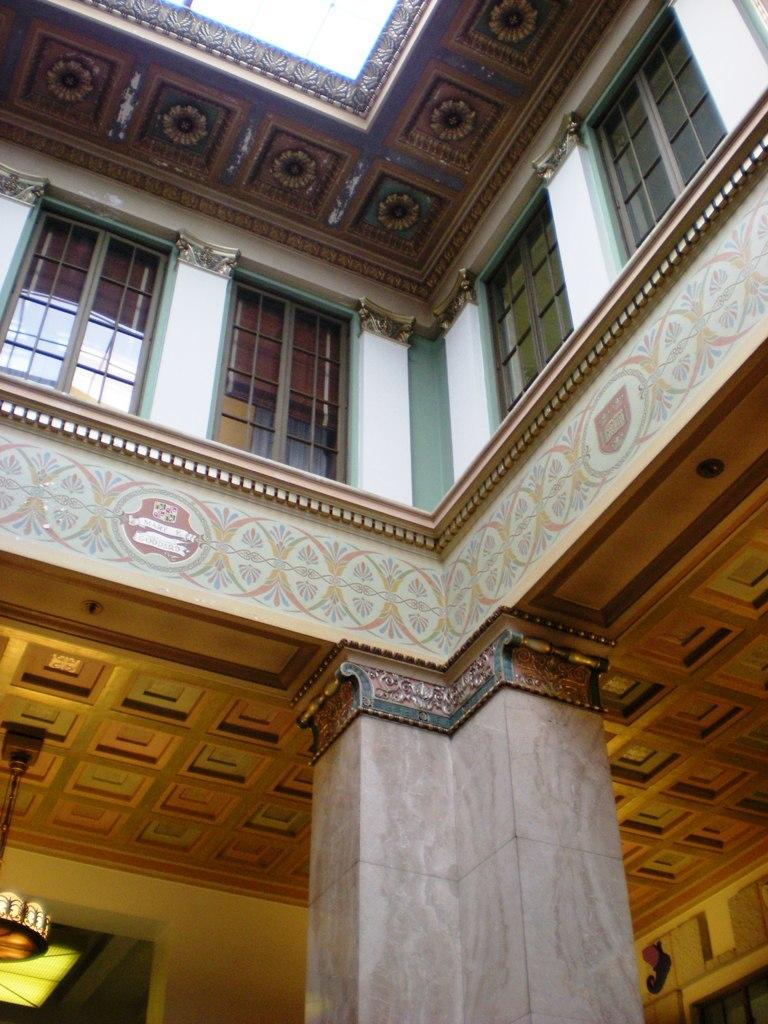What type of architectural feature can be seen in the image? There are doors and a pillar in the image. What is the pillar connected to in the image? The pillar is part of a building in the image. What type of bone can be seen in the image? There is no bone present in the image; it features doors and a pillar that are part of a building. 